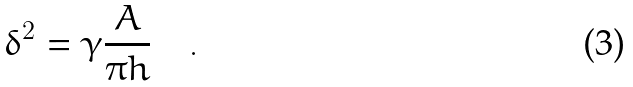Convert formula to latex. <formula><loc_0><loc_0><loc_500><loc_500>\delta ^ { 2 } = \gamma \frac { A } { \pi h } \quad .</formula> 